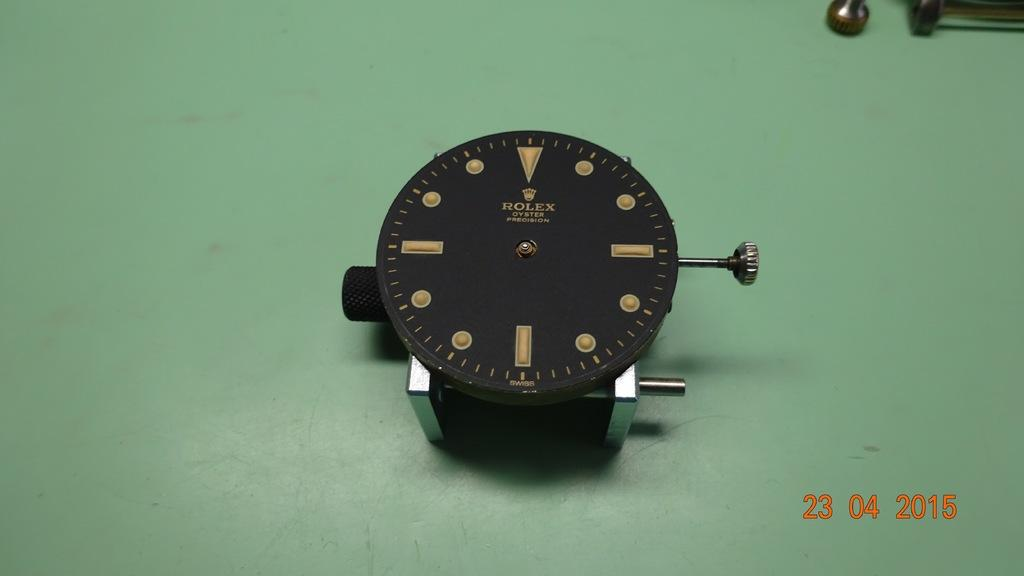<image>
Summarize the visual content of the image. The rolex watch is on the green table 